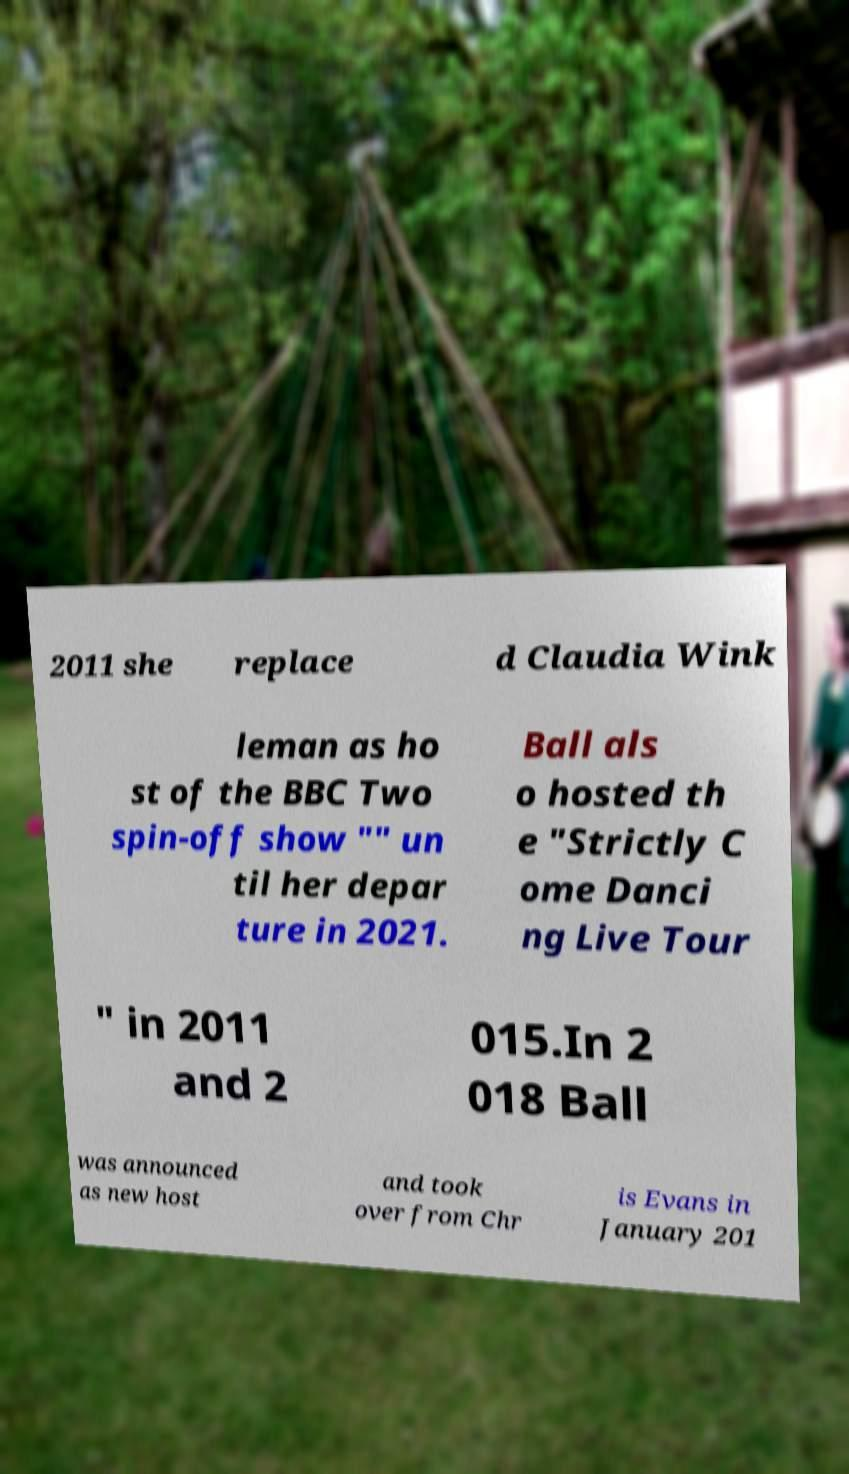Could you extract and type out the text from this image? 2011 she replace d Claudia Wink leman as ho st of the BBC Two spin-off show "" un til her depar ture in 2021. Ball als o hosted th e "Strictly C ome Danci ng Live Tour " in 2011 and 2 015.In 2 018 Ball was announced as new host and took over from Chr is Evans in January 201 